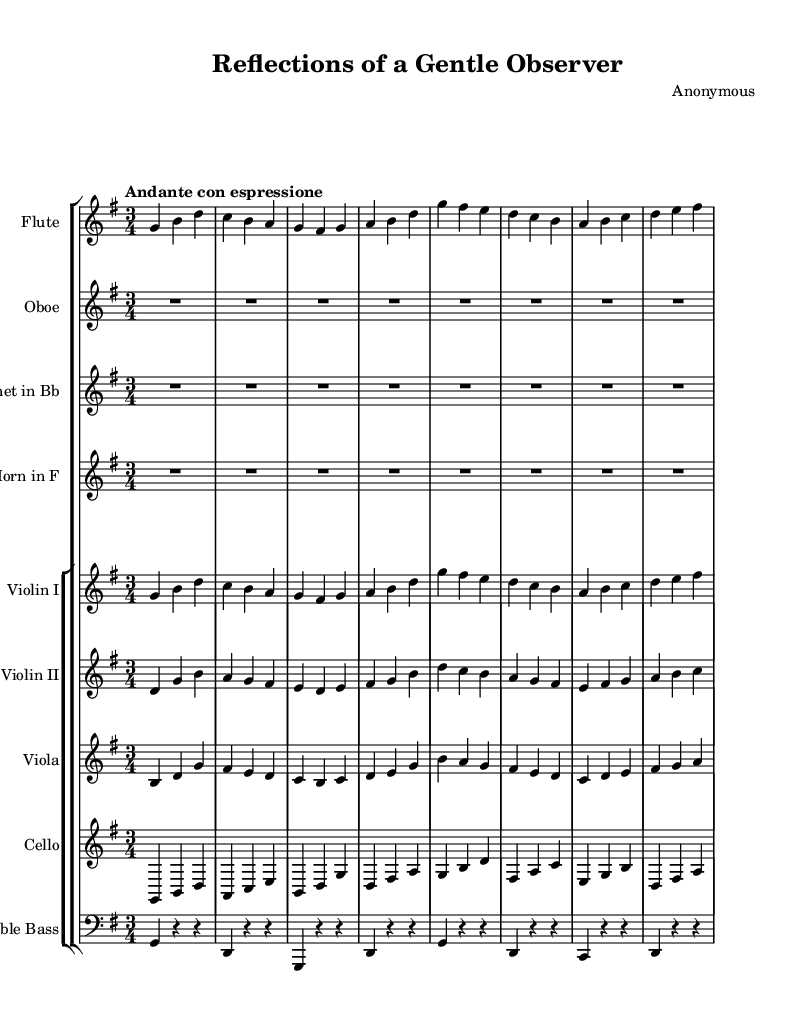What is the key signature of this music? The key signature is G major, which has one sharp (F#). This can be determined by looking at the key signature at the beginning of the staff.
Answer: G major What is the time signature of this music? The time signature is 3/4, indicated at the beginning of the score. This means there are three beats per measure, and the quarter note gets one beat.
Answer: 3/4 What is the tempo marking of this music? The tempo marking is "Andante con espressione," which suggests a moderately slow tempo with expression. This is indicated at the beginning of the score.
Answer: Andante con espressione Which instruments are featured in this symphony? The instruments featured are Flute, Oboe, Clarinet in Bb, Horn in F, Violin I, Violin II, Viola, Cello, and Double Bass. This information is found in the staff group layout at the beginning of the score.
Answer: Flute, Oboe, Clarinet in Bb, Horn in F, Violin I, Violin II, Viola, Cello, Double Bass How many measures are in the provided music portion? By counting the bar lines from the beginning to the end of the excerpt, there are a total of eight measures in the provided music portion.
Answer: Eight measures Which instrument has the highest pitch in this music? The Flute has the highest pitch. By analyzing the range of the instruments shown in the score, the flute typically plays higher than the others in the orchestration listed.
Answer: Flute 